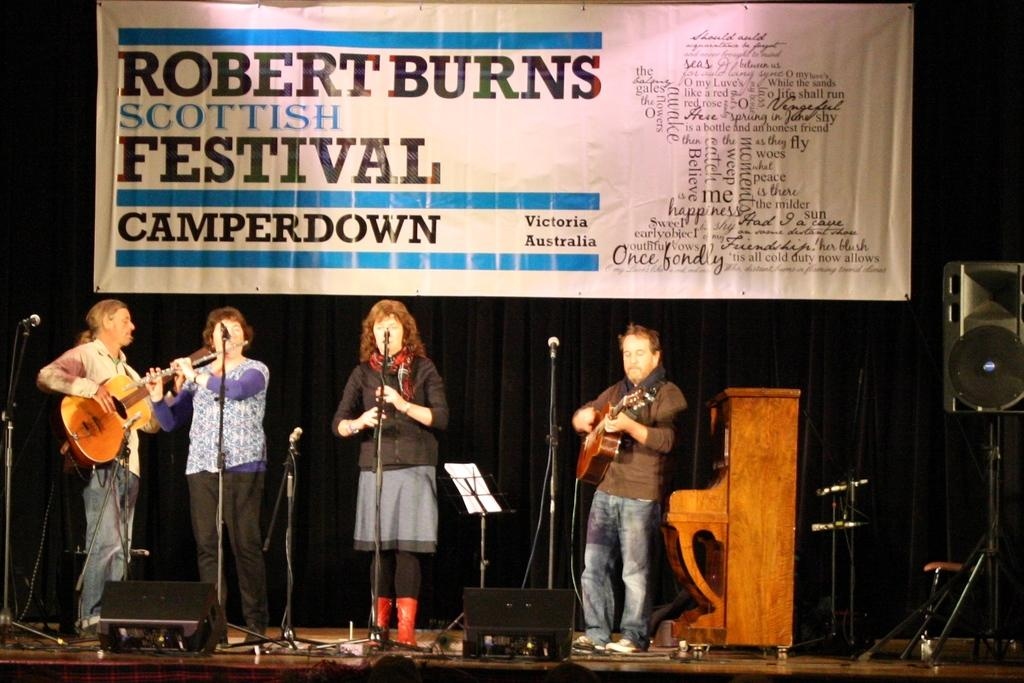How many people are in the image? There are four persons in the image. What are two of the persons doing in the image? Two of the persons are playing guitar. What are the other two persons doing in the image? The other two persons are singing on a microphone. Where does the scene take place? The scene takes place on a stage. What can be seen in the background of the image? In the background, there is a banner, speakers, and a table. What topic are the persons discussing during recess in the image? There is no indication of a discussion or recess in the image; the persons are playing guitar and singing on a stage. 